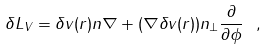<formula> <loc_0><loc_0><loc_500><loc_500>\delta L _ { V } = \delta v ( { r } ) { n } \nabla + ( \nabla \delta v ( { r } ) ) { n } _ { \perp } \frac { \partial } { \partial \phi } \ ,</formula> 